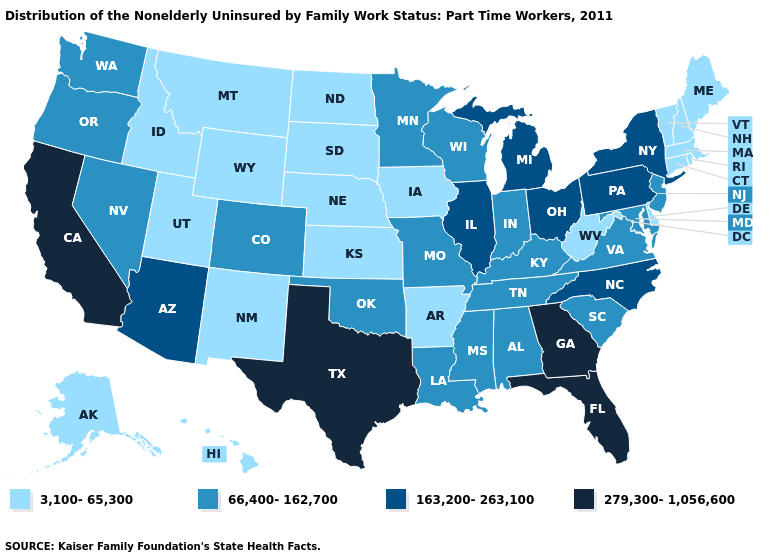Does the first symbol in the legend represent the smallest category?
Keep it brief. Yes. What is the value of Maryland?
Keep it brief. 66,400-162,700. Name the states that have a value in the range 163,200-263,100?
Keep it brief. Arizona, Illinois, Michigan, New York, North Carolina, Ohio, Pennsylvania. Name the states that have a value in the range 163,200-263,100?
Quick response, please. Arizona, Illinois, Michigan, New York, North Carolina, Ohio, Pennsylvania. Which states have the lowest value in the USA?
Be succinct. Alaska, Arkansas, Connecticut, Delaware, Hawaii, Idaho, Iowa, Kansas, Maine, Massachusetts, Montana, Nebraska, New Hampshire, New Mexico, North Dakota, Rhode Island, South Dakota, Utah, Vermont, West Virginia, Wyoming. Is the legend a continuous bar?
Be succinct. No. Does Arizona have a lower value than Kentucky?
Keep it brief. No. Does Texas have the highest value in the USA?
Give a very brief answer. Yes. What is the value of Indiana?
Short answer required. 66,400-162,700. Which states have the lowest value in the USA?
Concise answer only. Alaska, Arkansas, Connecticut, Delaware, Hawaii, Idaho, Iowa, Kansas, Maine, Massachusetts, Montana, Nebraska, New Hampshire, New Mexico, North Dakota, Rhode Island, South Dakota, Utah, Vermont, West Virginia, Wyoming. What is the value of Maryland?
Keep it brief. 66,400-162,700. What is the value of Delaware?
Short answer required. 3,100-65,300. What is the highest value in the USA?
Give a very brief answer. 279,300-1,056,600. What is the value of Delaware?
Keep it brief. 3,100-65,300. 